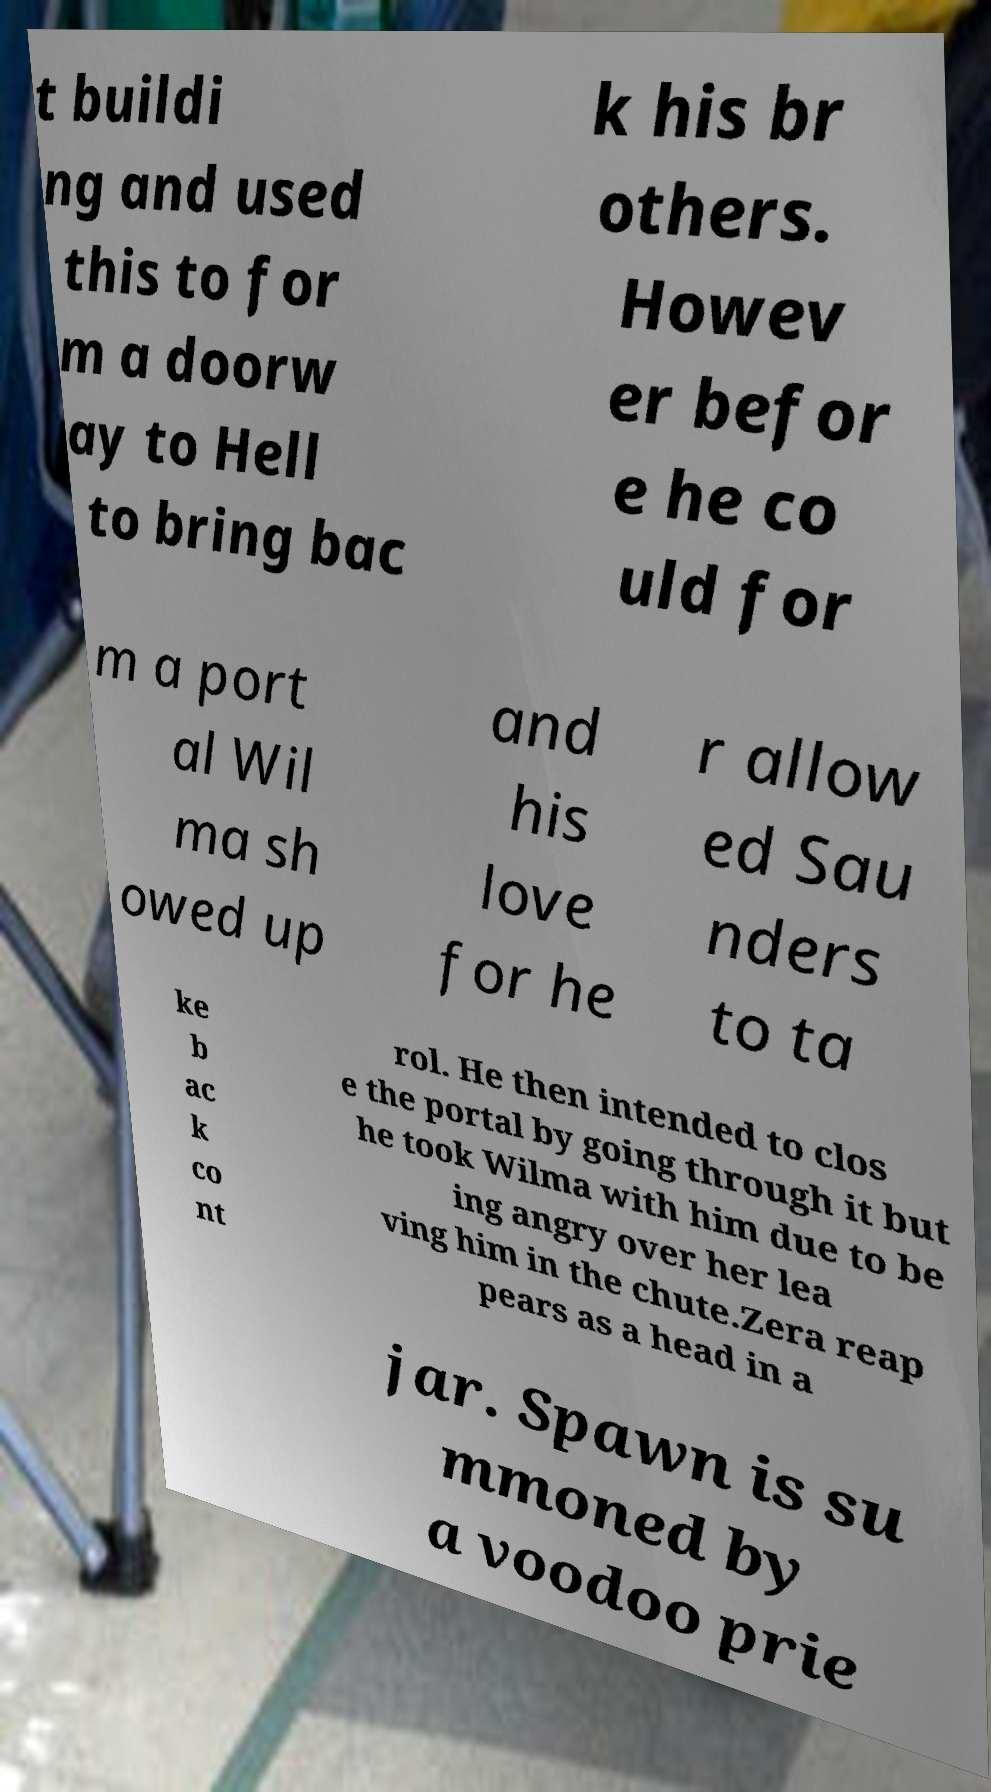For documentation purposes, I need the text within this image transcribed. Could you provide that? t buildi ng and used this to for m a doorw ay to Hell to bring bac k his br others. Howev er befor e he co uld for m a port al Wil ma sh owed up and his love for he r allow ed Sau nders to ta ke b ac k co nt rol. He then intended to clos e the portal by going through it but he took Wilma with him due to be ing angry over her lea ving him in the chute.Zera reap pears as a head in a jar. Spawn is su mmoned by a voodoo prie 